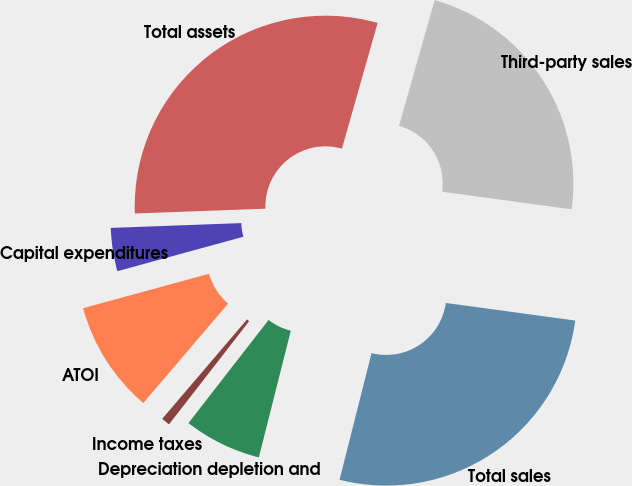<chart> <loc_0><loc_0><loc_500><loc_500><pie_chart><fcel>Third-party sales<fcel>Total sales<fcel>Depreciation depletion and<fcel>Income taxes<fcel>ATOI<fcel>Capital expenditures<fcel>Total assets<nl><fcel>22.75%<fcel>26.78%<fcel>6.58%<fcel>0.73%<fcel>9.51%<fcel>3.66%<fcel>29.99%<nl></chart> 